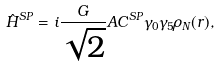Convert formula to latex. <formula><loc_0><loc_0><loc_500><loc_500>\hat { H } ^ { S P } = i \frac { G } { \sqrt { 2 } } A C ^ { S P } \gamma _ { 0 } \gamma _ { 5 } \rho _ { N } ( r ) ,</formula> 